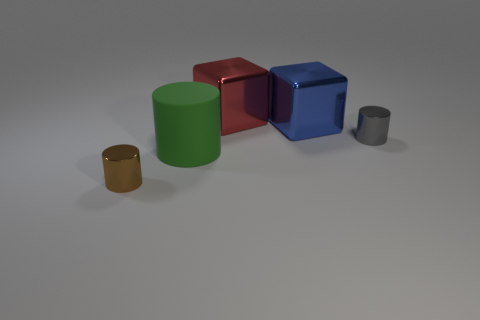What is the tiny object that is in front of the gray thing made of?
Your answer should be compact. Metal. What number of other objects are the same size as the gray metal thing?
Offer a terse response. 1. Are there fewer brown things than tiny spheres?
Give a very brief answer. No. There is a big green object; what shape is it?
Keep it short and to the point. Cylinder. There is a small shiny object to the right of the tiny brown cylinder; is it the same color as the large rubber cylinder?
Give a very brief answer. No. The thing that is in front of the big blue metal block and behind the large cylinder has what shape?
Ensure brevity in your answer.  Cylinder. What color is the small thing behind the tiny brown cylinder?
Provide a short and direct response. Gray. Are there any other things of the same color as the large rubber object?
Ensure brevity in your answer.  No. Do the red shiny thing and the green thing have the same size?
Ensure brevity in your answer.  Yes. How big is the metallic thing that is both in front of the big blue shiny object and behind the green object?
Provide a short and direct response. Small. 